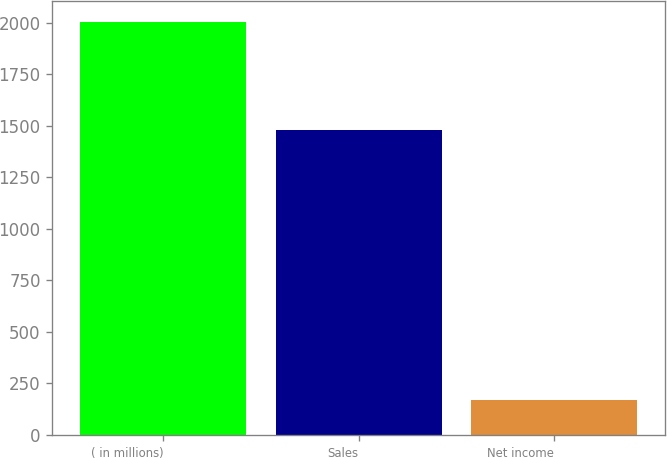Convert chart to OTSL. <chart><loc_0><loc_0><loc_500><loc_500><bar_chart><fcel>( in millions)<fcel>Sales<fcel>Net income<nl><fcel>2006<fcel>1479<fcel>170<nl></chart> 